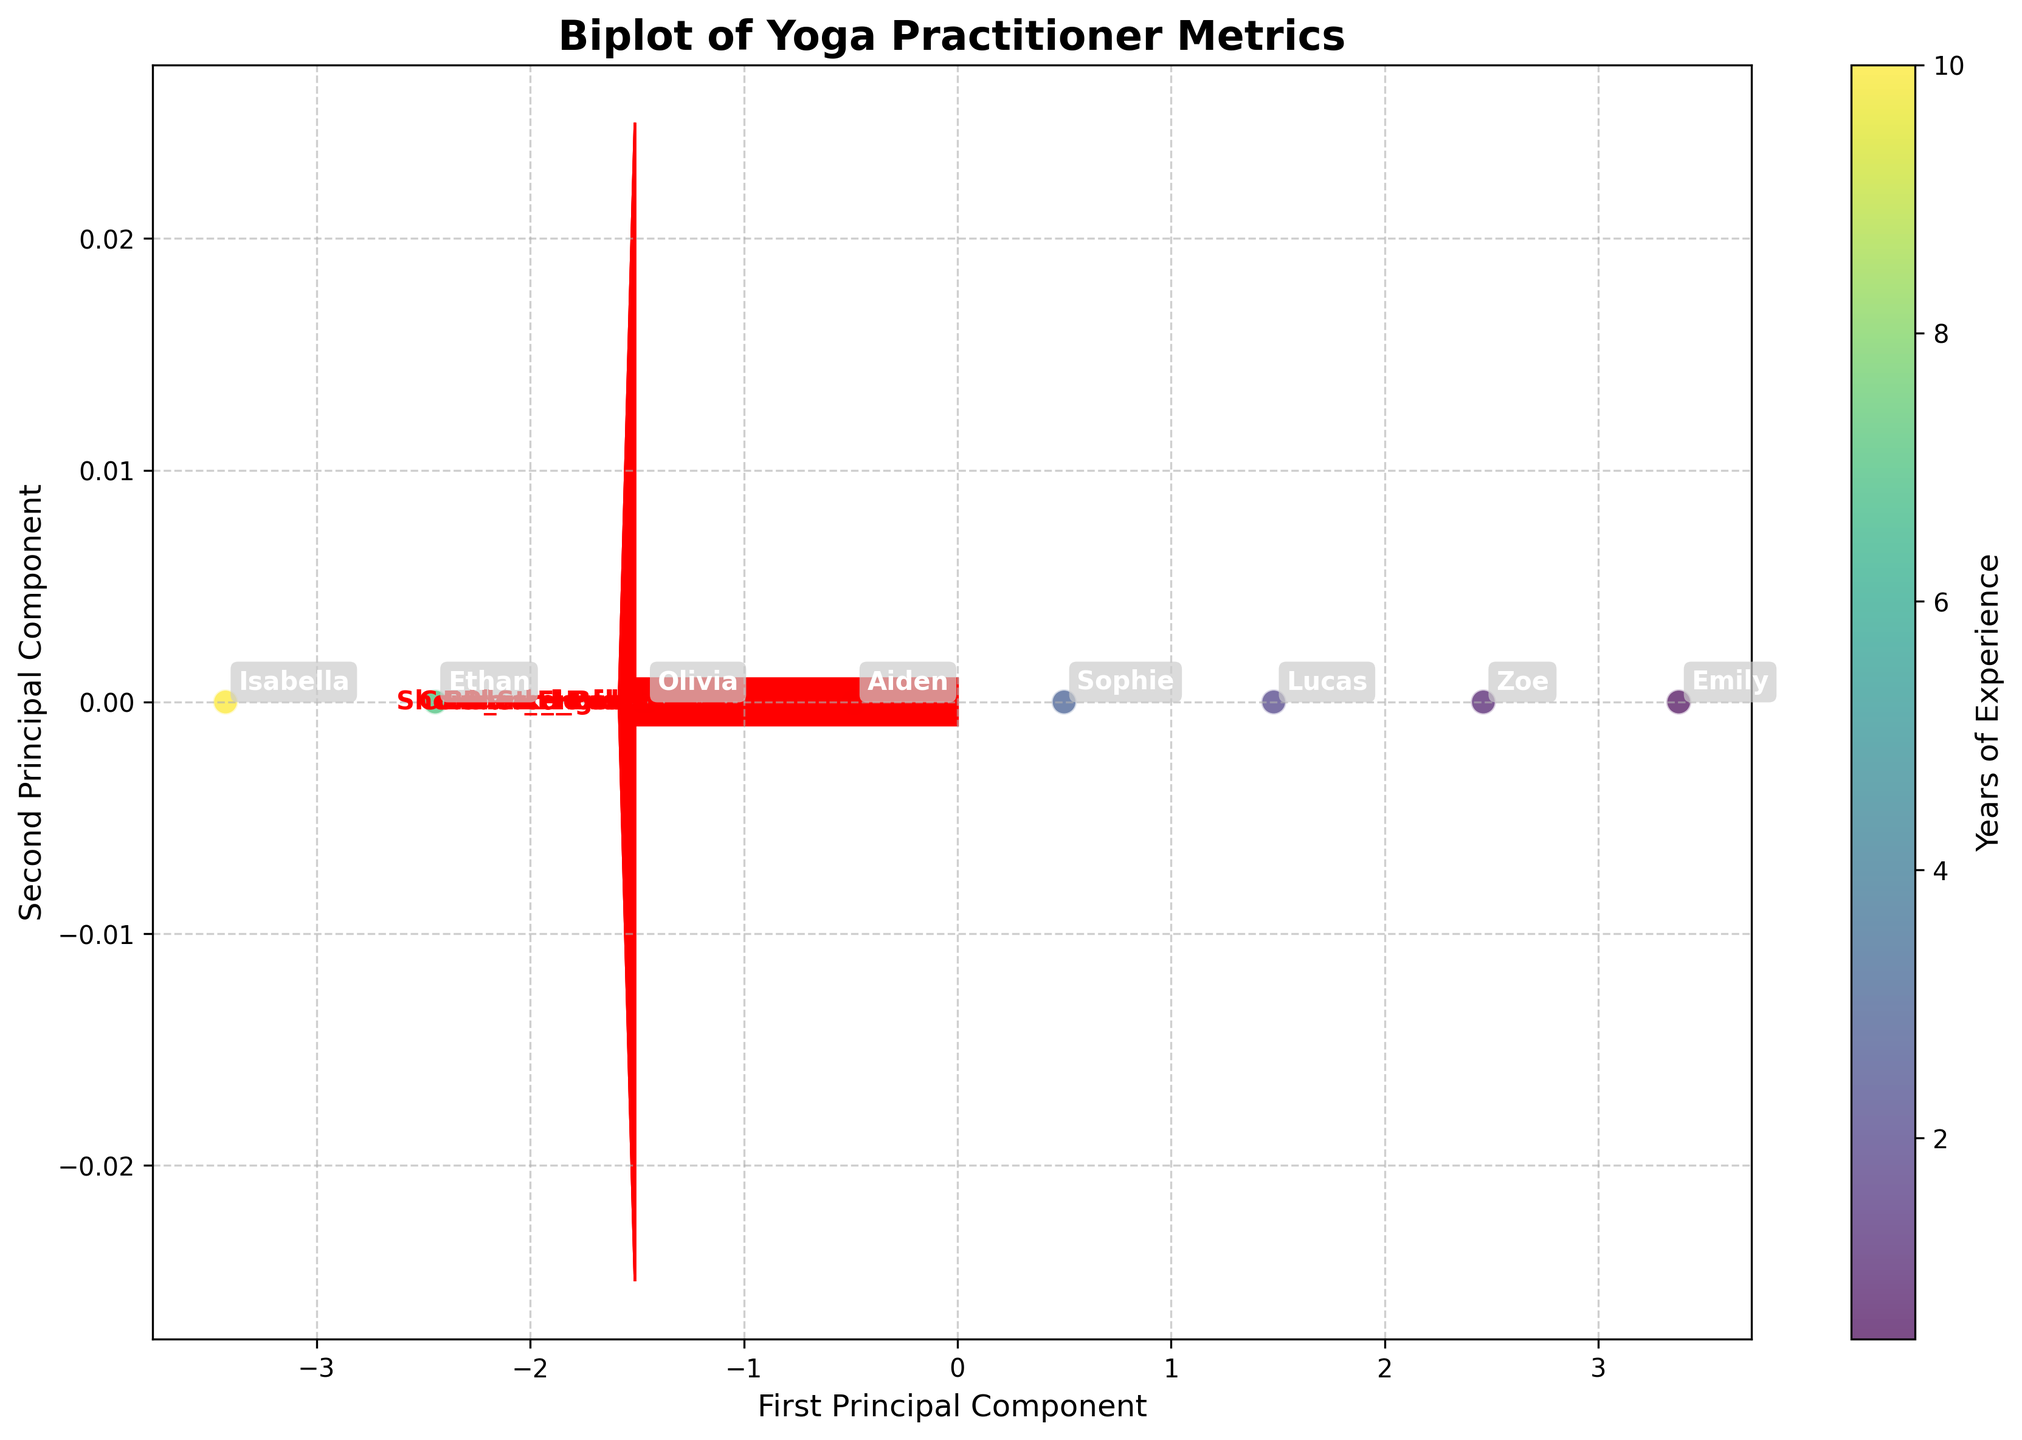What is the title of the figure? The title is displayed clearly at the top of the figure in bold text. It helps viewers understand what the chart is about.
Answer: Biplot of Yoga Practitioner Metrics How many practitioners are included in the figure? Each point on the plot represents one practitioner, and they are annotated with their names. By counting these annotations, we can determine the number of practitioners.
Answer: 8 Which metric has the highest influence on the first principal component? The directions of the arrows represent the influence of each metric on the principal components. The arrow with the longest projection on the first principal component axis indicates the highest influence.
Answer: Core_Strength_rating What color represents the most experienced practitioner? The colorbar on the right indicates years of experience, with the most intense color (darkest) representing the highest value.
Answer: Dark purple How are the practitioners distributed with respect to the first and second principal components? Look at the plot positions and note the spread of practitioners along both principal components. It shows how practitioners differ based on these components.
Answer: The practitioners are distributed diagonally from bottom-left to top-right Which practitioner has the highest forward bend flexibility and where is she located on the plot? The practitioner with the highest forward bend flexibility will be located towards the end of the arrow representing 'Forward_Bend_cm'. Identify the name annotated near this point.
Answer: Isabella Compare the core strength rating of Lucas and Sophie. Who has a higher rating? Locate the positions of Lucas and Sophie on the plot. Note their distances from the origin along the arrow representing 'Core_Strength_rating'.
Answer: Sophie Which metric seems least informative based on the length of its vector in the biplot? The shortest arrow on the plot indicates the metric with the least variability explained by the principal components.
Answer: Forward_Bend_cm Which practitioners have balance poses of more than 70 seconds? Identify the position of the 'Balance_Pose_sec' arrow and check for practitioners who are located along or beyond the part of the arrow representing 70 seconds.
Answer: Aiden, Olivia, Ethan, Isabella 